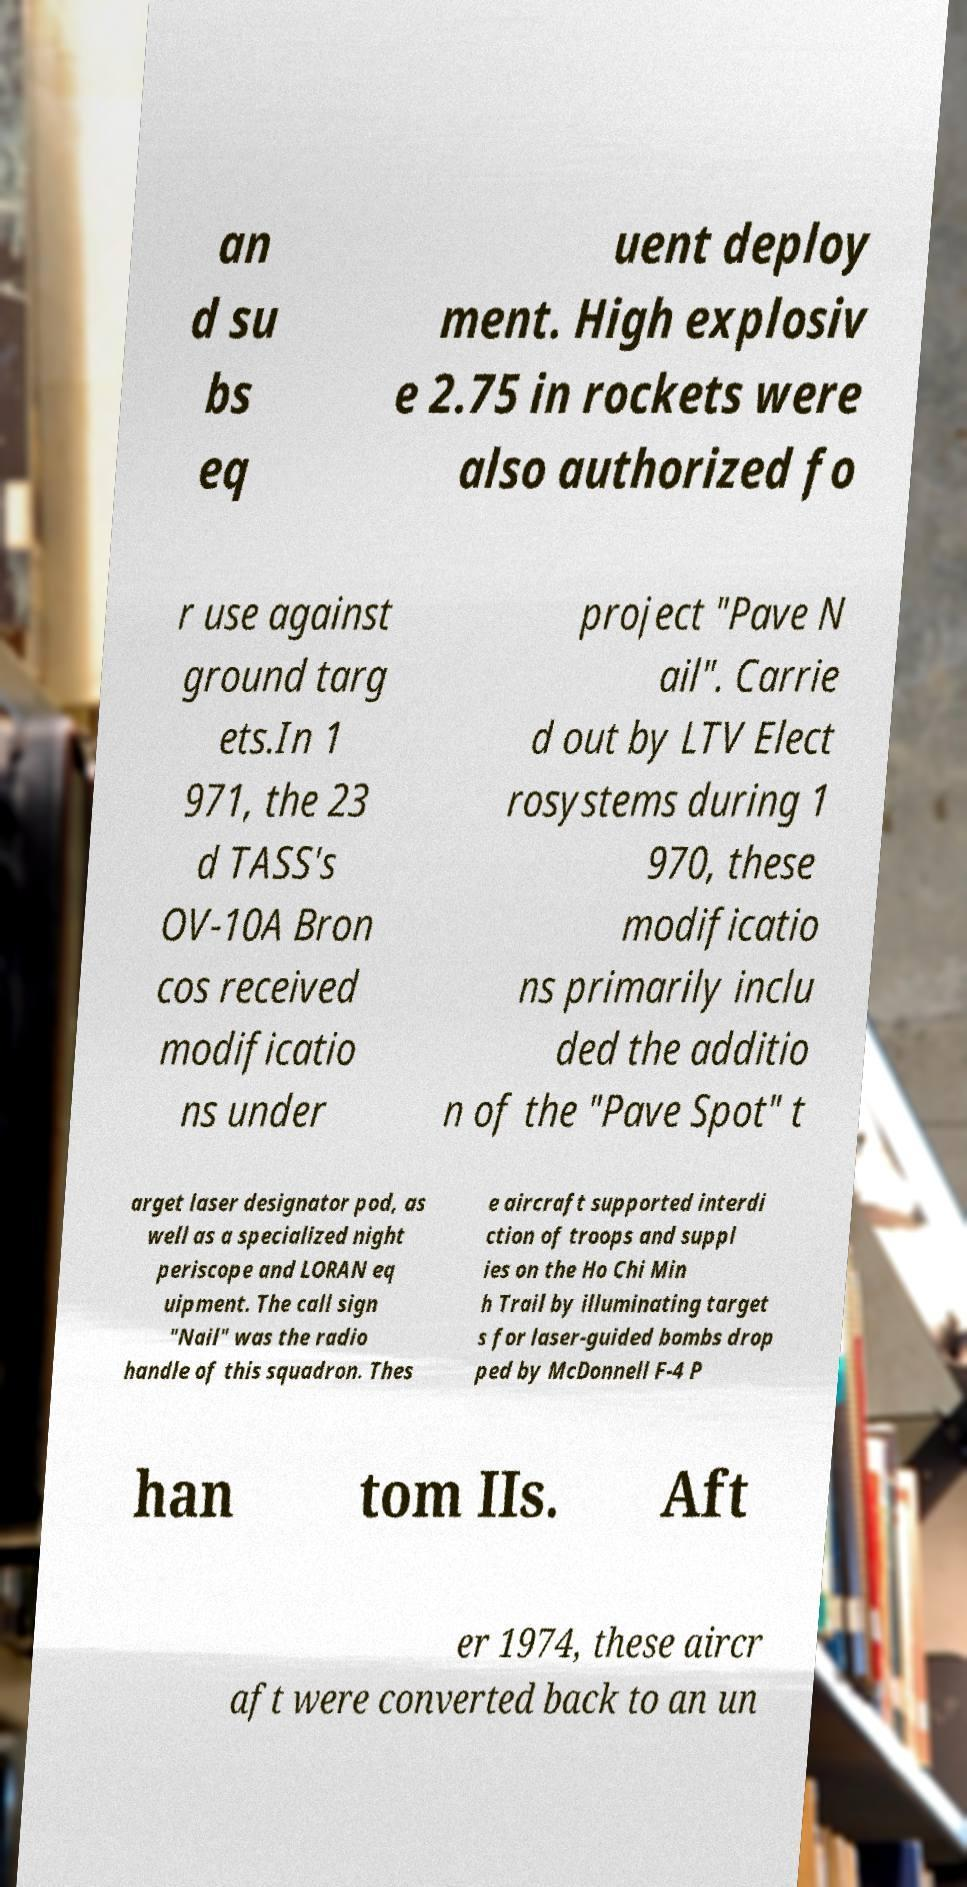Could you assist in decoding the text presented in this image and type it out clearly? an d su bs eq uent deploy ment. High explosiv e 2.75 in rockets were also authorized fo r use against ground targ ets.In 1 971, the 23 d TASS's OV-10A Bron cos received modificatio ns under project "Pave N ail". Carrie d out by LTV Elect rosystems during 1 970, these modificatio ns primarily inclu ded the additio n of the "Pave Spot" t arget laser designator pod, as well as a specialized night periscope and LORAN eq uipment. The call sign "Nail" was the radio handle of this squadron. Thes e aircraft supported interdi ction of troops and suppl ies on the Ho Chi Min h Trail by illuminating target s for laser-guided bombs drop ped by McDonnell F-4 P han tom IIs. Aft er 1974, these aircr aft were converted back to an un 